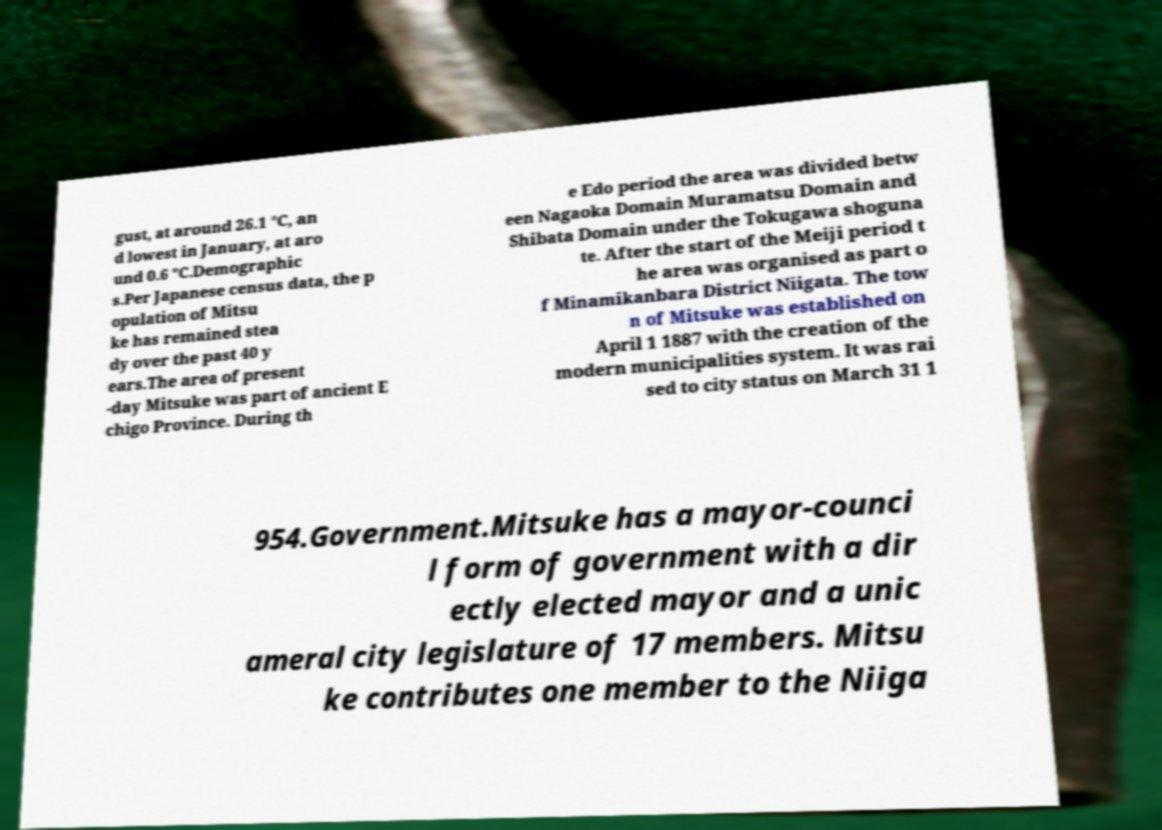Please identify and transcribe the text found in this image. gust, at around 26.1 °C, an d lowest in January, at aro und 0.6 °C.Demographic s.Per Japanese census data, the p opulation of Mitsu ke has remained stea dy over the past 40 y ears.The area of present -day Mitsuke was part of ancient E chigo Province. During th e Edo period the area was divided betw een Nagaoka Domain Muramatsu Domain and Shibata Domain under the Tokugawa shoguna te. After the start of the Meiji period t he area was organised as part o f Minamikanbara District Niigata. The tow n of Mitsuke was established on April 1 1887 with the creation of the modern municipalities system. It was rai sed to city status on March 31 1 954.Government.Mitsuke has a mayor-counci l form of government with a dir ectly elected mayor and a unic ameral city legislature of 17 members. Mitsu ke contributes one member to the Niiga 